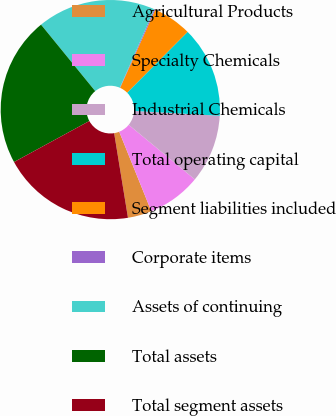<chart> <loc_0><loc_0><loc_500><loc_500><pie_chart><fcel>Agricultural Products<fcel>Specialty Chemicals<fcel>Industrial Chemicals<fcel>Total operating capital<fcel>Segment liabilities included<fcel>Corporate items<fcel>Assets of continuing<fcel>Total assets<fcel>Total segment assets<nl><fcel>3.53%<fcel>7.91%<fcel>10.09%<fcel>13.44%<fcel>5.72%<fcel>0.17%<fcel>17.45%<fcel>22.05%<fcel>19.64%<nl></chart> 